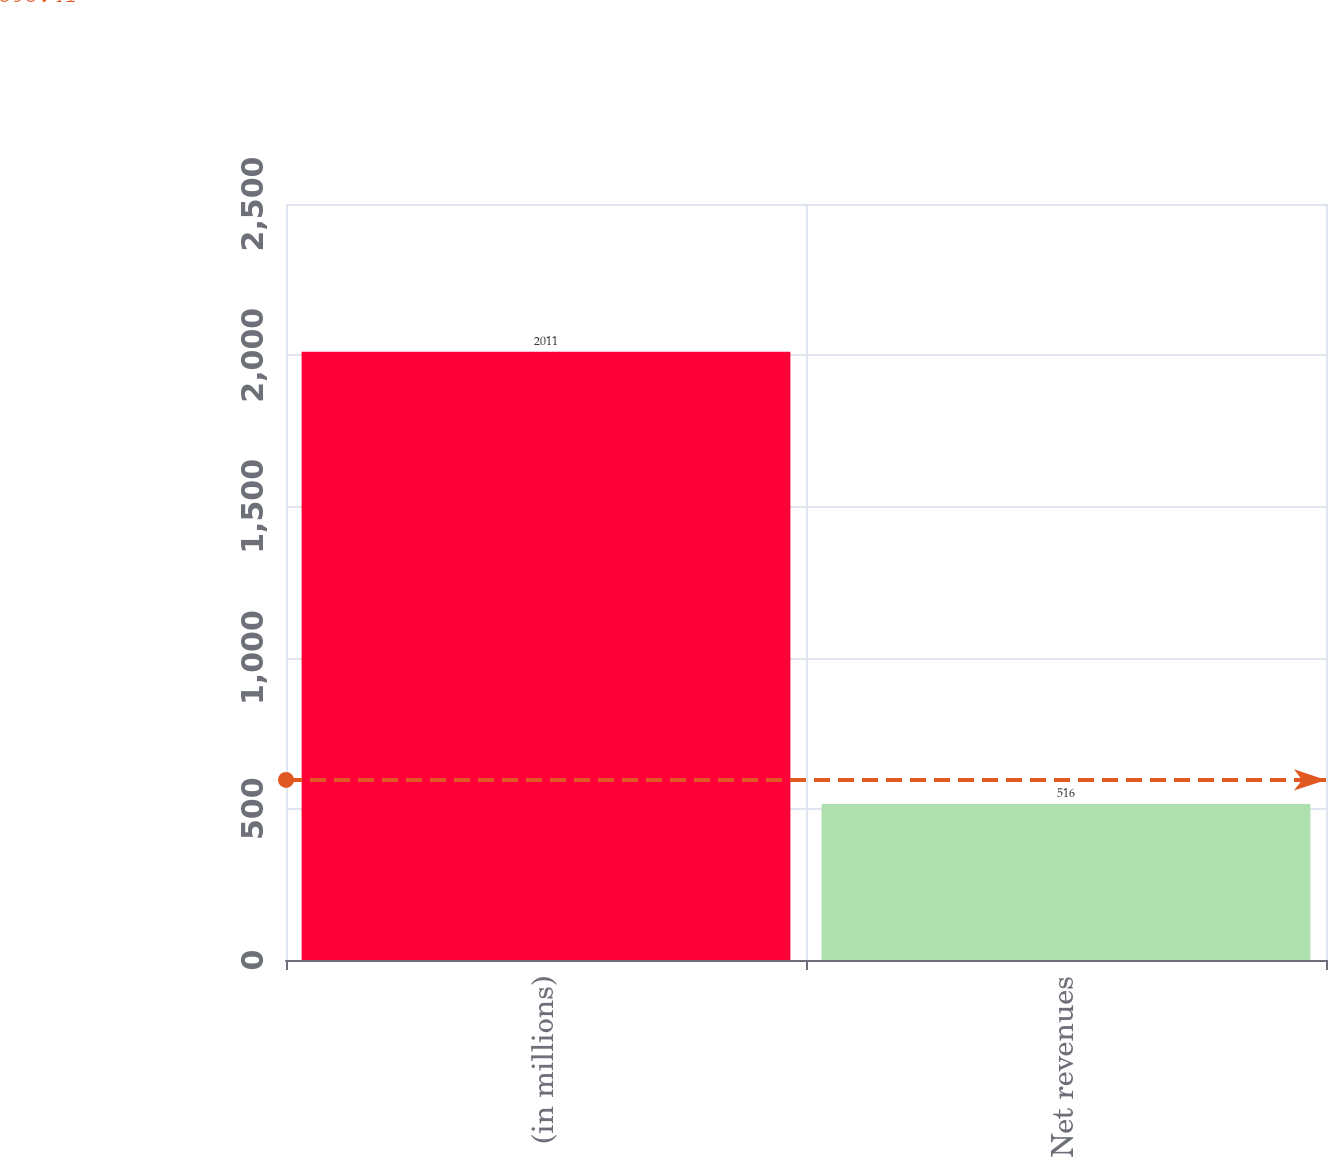Convert chart. <chart><loc_0><loc_0><loc_500><loc_500><bar_chart><fcel>(in millions)<fcel>Net revenues<nl><fcel>2011<fcel>516<nl></chart> 